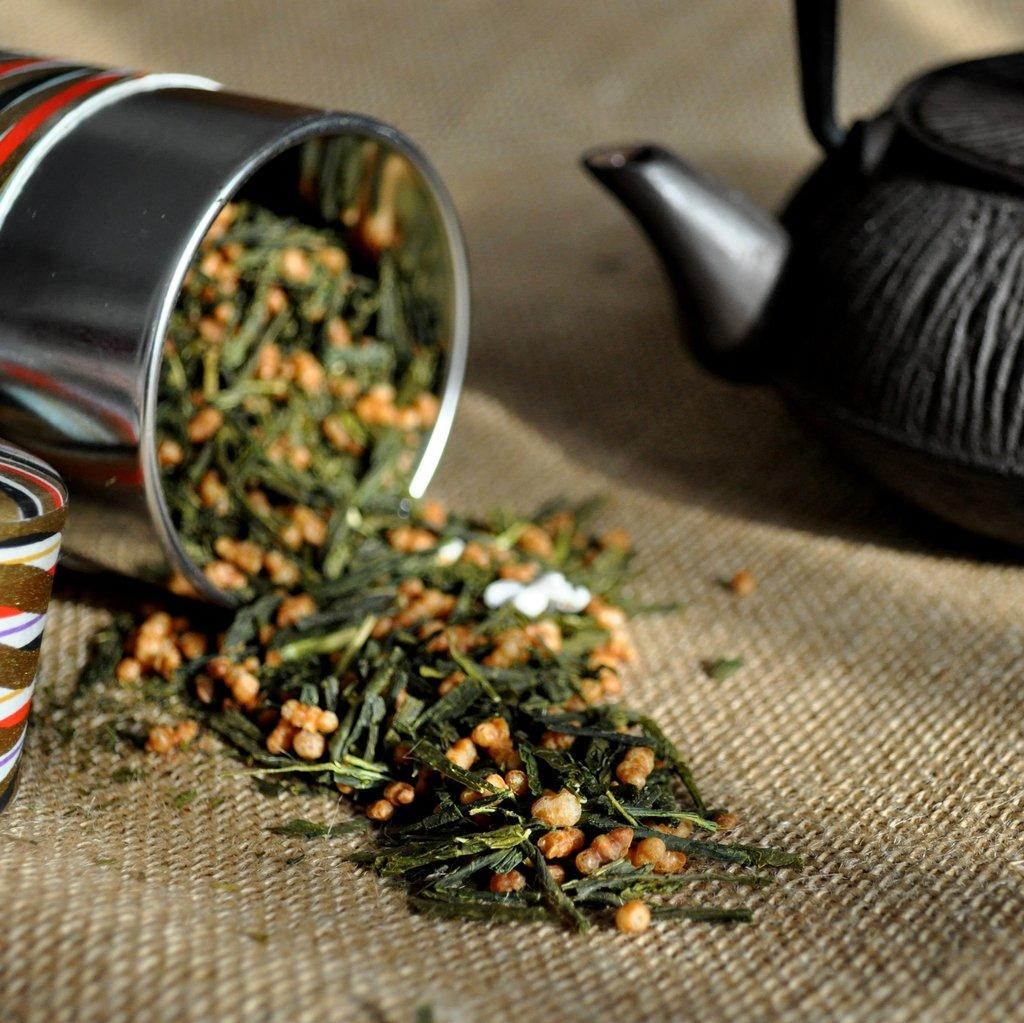What is the main object on the cloth in the image? There is a teapot on the cloth. What else is on the cloth besides the teapot? There is a container on the cloth. What is inside the container? The container has tea leaves inside it. What type of oil can be seen dripping from the teapot in the image? There is no oil present in the image, and the teapot does not appear to be dripping anything. 